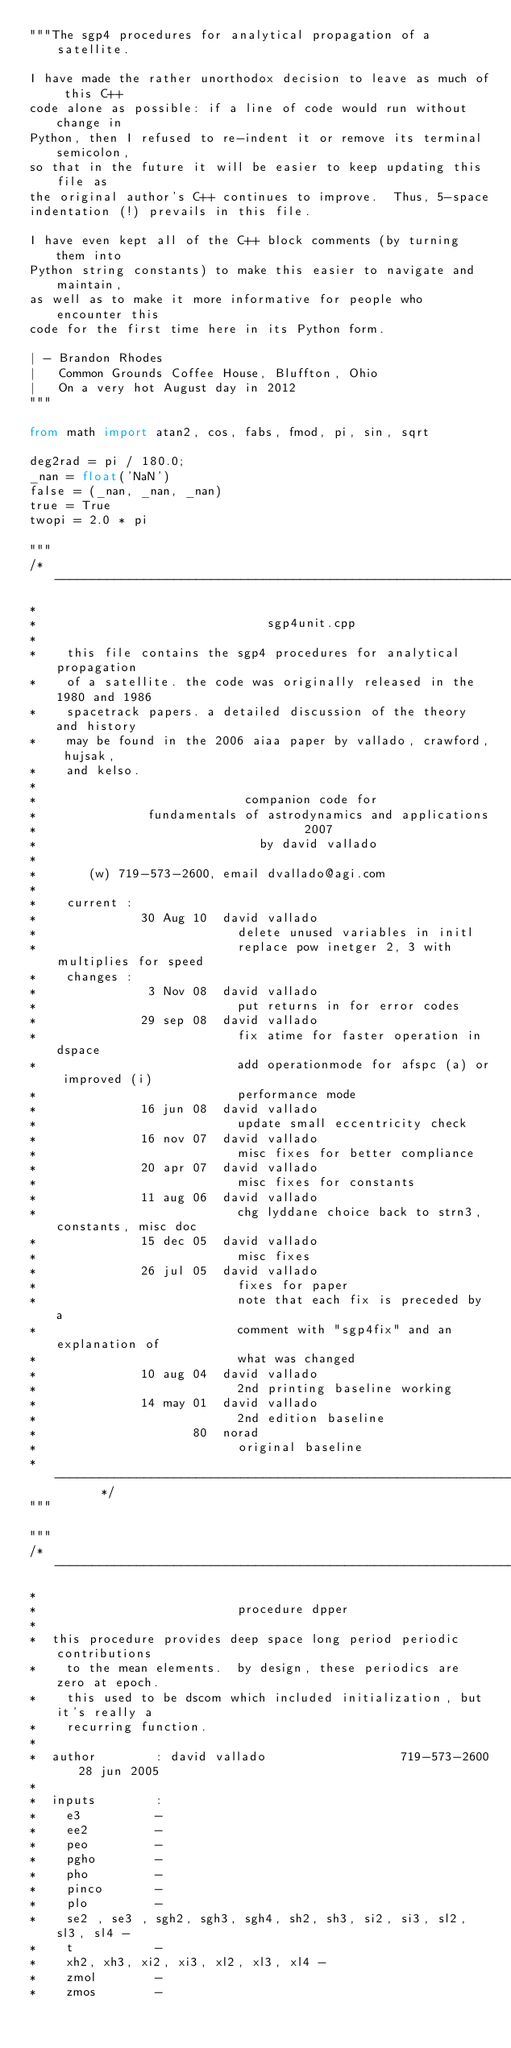Convert code to text. <code><loc_0><loc_0><loc_500><loc_500><_Python_>"""The sgp4 procedures for analytical propagation of a satellite.

I have made the rather unorthodox decision to leave as much of this C++
code alone as possible: if a line of code would run without change in
Python, then I refused to re-indent it or remove its terminal semicolon,
so that in the future it will be easier to keep updating this file as
the original author's C++ continues to improve.  Thus, 5-space
indentation (!) prevails in this file.

I have even kept all of the C++ block comments (by turning them into
Python string constants) to make this easier to navigate and maintain,
as well as to make it more informative for people who encounter this
code for the first time here in its Python form.

| - Brandon Rhodes
|   Common Grounds Coffee House, Bluffton, Ohio
|   On a very hot August day in 2012
"""

from math import atan2, cos, fabs, fmod, pi, sin, sqrt

deg2rad = pi / 180.0;
_nan = float('NaN')
false = (_nan, _nan, _nan)
true = True
twopi = 2.0 * pi

"""
/*     ----------------------------------------------------------------
*
*                               sgp4unit.cpp
*
*    this file contains the sgp4 procedures for analytical propagation
*    of a satellite. the code was originally released in the 1980 and 1986
*    spacetrack papers. a detailed discussion of the theory and history
*    may be found in the 2006 aiaa paper by vallado, crawford, hujsak,
*    and kelso.
*
*                            companion code for
*               fundamentals of astrodynamics and applications
*                                    2007
*                              by david vallado
*
*       (w) 719-573-2600, email dvallado@agi.com
*
*    current :
*              30 Aug 10  david vallado
*                           delete unused variables in initl
*                           replace pow inetger 2, 3 with multiplies for speed
*    changes :
*               3 Nov 08  david vallado
*                           put returns in for error codes
*              29 sep 08  david vallado
*                           fix atime for faster operation in dspace
*                           add operationmode for afspc (a) or improved (i)
*                           performance mode
*              16 jun 08  david vallado
*                           update small eccentricity check
*              16 nov 07  david vallado
*                           misc fixes for better compliance
*              20 apr 07  david vallado
*                           misc fixes for constants
*              11 aug 06  david vallado
*                           chg lyddane choice back to strn3, constants, misc doc
*              15 dec 05  david vallado
*                           misc fixes
*              26 jul 05  david vallado
*                           fixes for paper
*                           note that each fix is preceded by a
*                           comment with "sgp4fix" and an explanation of
*                           what was changed
*              10 aug 04  david vallado
*                           2nd printing baseline working
*              14 may 01  david vallado
*                           2nd edition baseline
*                     80  norad
*                           original baseline
*       ----------------------------------------------------------------      */
"""

"""
/* -----------------------------------------------------------------------------
*
*                           procedure dpper
*
*  this procedure provides deep space long period periodic contributions
*    to the mean elements.  by design, these periodics are zero at epoch.
*    this used to be dscom which included initialization, but it's really a
*    recurring function.
*
*  author        : david vallado                  719-573-2600   28 jun 2005
*
*  inputs        :
*    e3          -
*    ee2         -
*    peo         -
*    pgho        -
*    pho         -
*    pinco       -
*    plo         -
*    se2 , se3 , sgh2, sgh3, sgh4, sh2, sh3, si2, si3, sl2, sl3, sl4 -
*    t           -
*    xh2, xh3, xi2, xi3, xl2, xl3, xl4 -
*    zmol        -
*    zmos        -</code> 